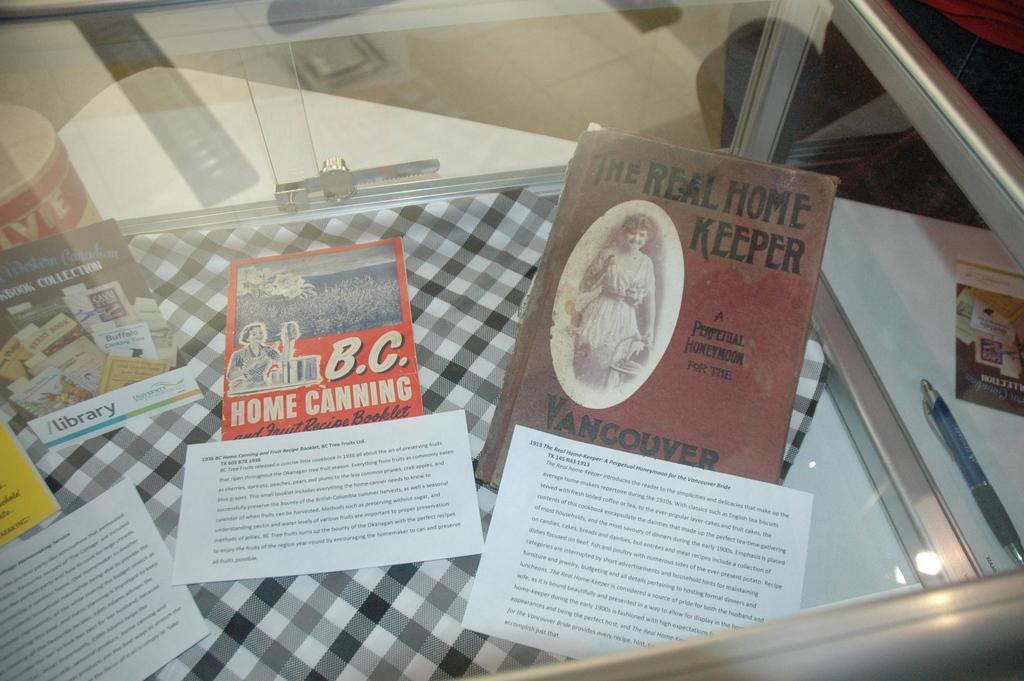<image>
Render a clear and concise summary of the photo. The book The Real Home Keeper is in a glass display with three other books. 